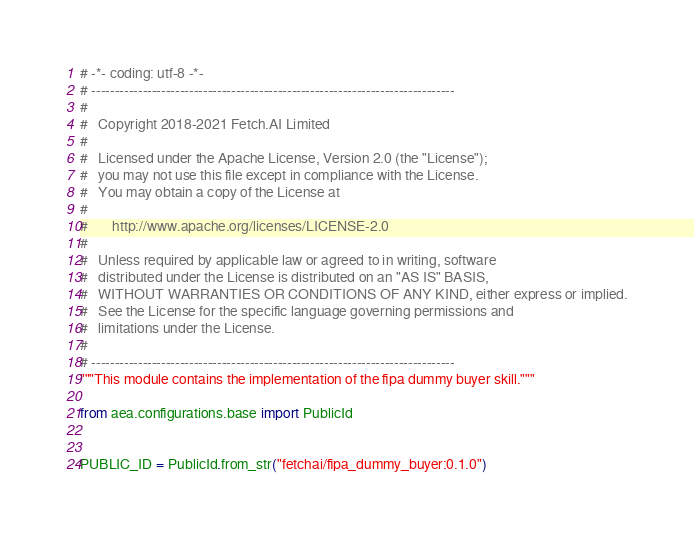<code> <loc_0><loc_0><loc_500><loc_500><_Python_># -*- coding: utf-8 -*-
# ------------------------------------------------------------------------------
#
#   Copyright 2018-2021 Fetch.AI Limited
#
#   Licensed under the Apache License, Version 2.0 (the "License");
#   you may not use this file except in compliance with the License.
#   You may obtain a copy of the License at
#
#       http://www.apache.org/licenses/LICENSE-2.0
#
#   Unless required by applicable law or agreed to in writing, software
#   distributed under the License is distributed on an "AS IS" BASIS,
#   WITHOUT WARRANTIES OR CONDITIONS OF ANY KIND, either express or implied.
#   See the License for the specific language governing permissions and
#   limitations under the License.
#
# ------------------------------------------------------------------------------
"""This module contains the implementation of the fipa dummy buyer skill."""

from aea.configurations.base import PublicId


PUBLIC_ID = PublicId.from_str("fetchai/fipa_dummy_buyer:0.1.0")
</code> 